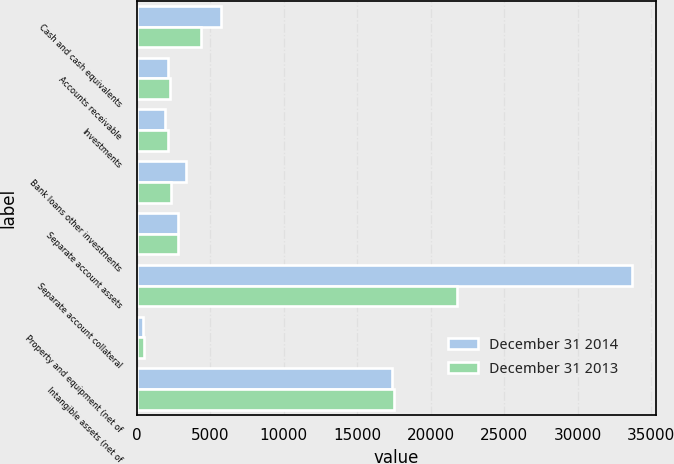Convert chart. <chart><loc_0><loc_0><loc_500><loc_500><stacked_bar_chart><ecel><fcel>Cash and cash equivalents<fcel>Accounts receivable<fcel>Investments<fcel>Bank loans other investments<fcel>Separate account assets<fcel>Separate account collateral<fcel>Property and equipment (net of<fcel>Intangible assets (net of<nl><fcel>December 31 2014<fcel>5723<fcel>2120<fcel>1921<fcel>3352<fcel>2838.5<fcel>33654<fcel>467<fcel>17344<nl><fcel>December 31 2013<fcel>4390<fcel>2247<fcel>2151<fcel>2325<fcel>2838.5<fcel>21788<fcel>525<fcel>17501<nl></chart> 